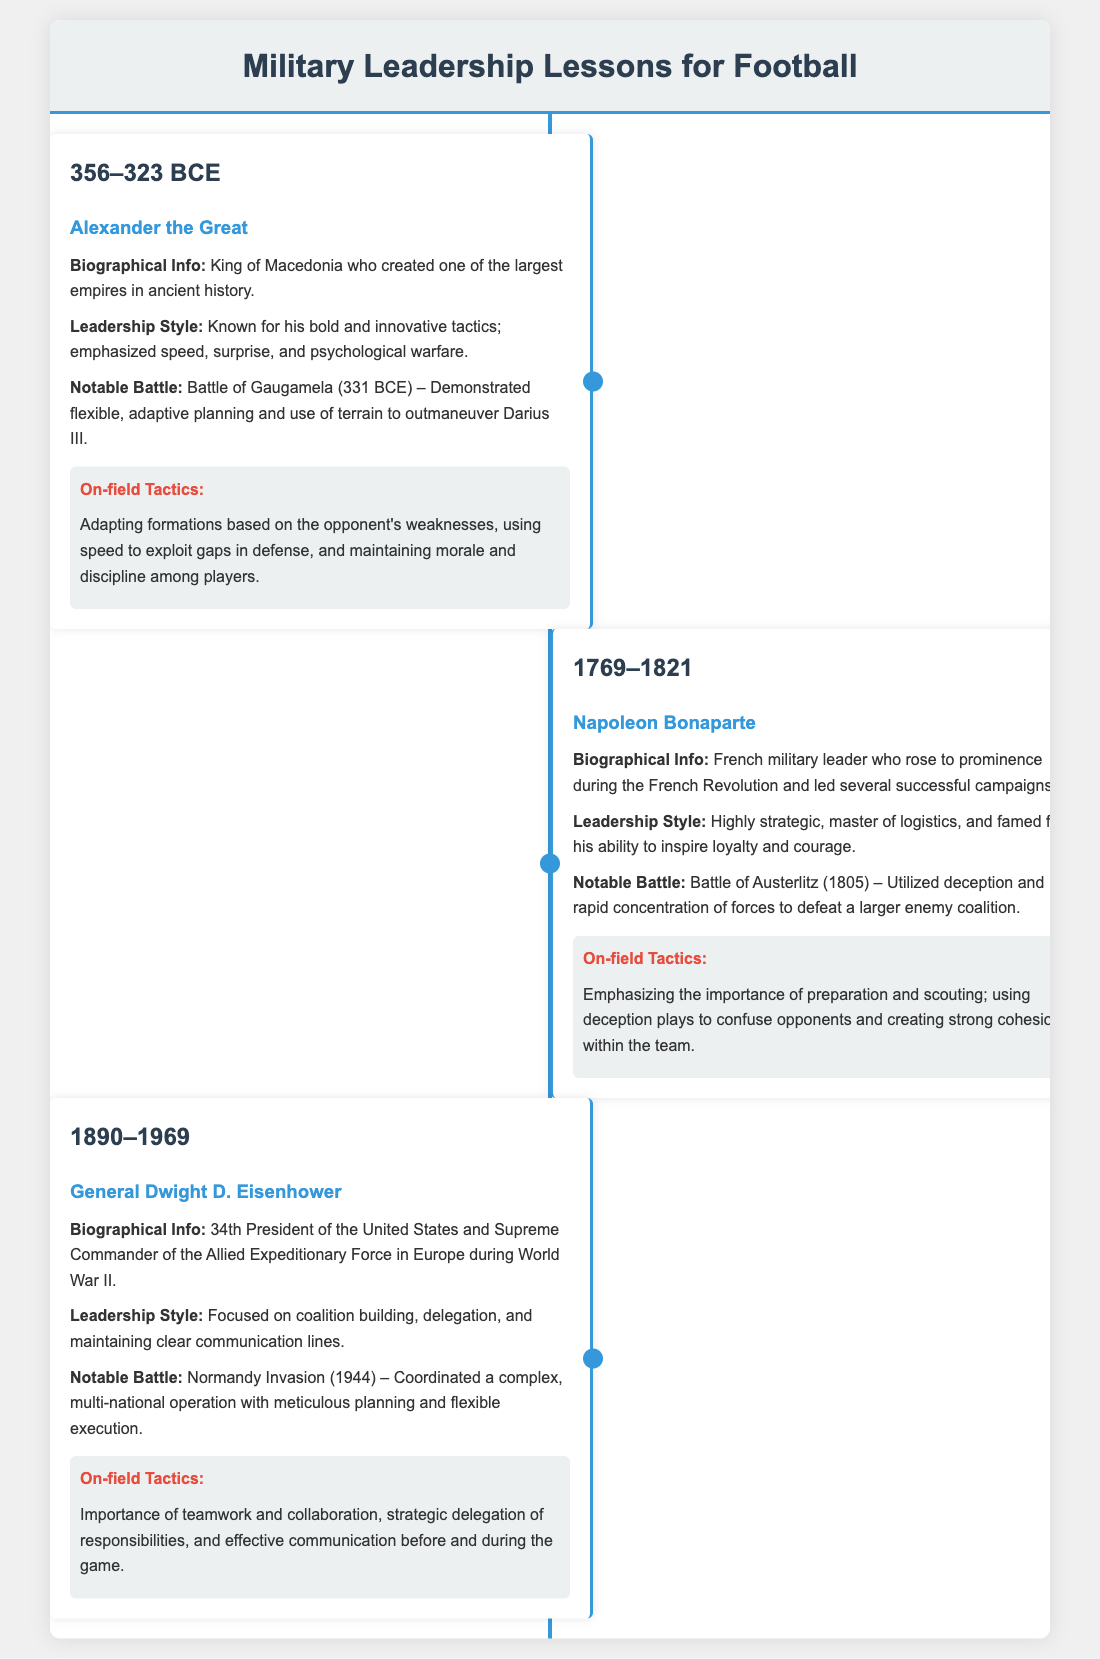What years did Alexander the Great live? The document states that Alexander the Great lived from 356 to 323 BCE.
Answer: 356–323 BCE Who was the Supreme Commander during the Normandy Invasion? The document indicates that General Dwight D. Eisenhower was the Supreme Commander of the Allied Expeditionary Force during this operation.
Answer: General Dwight D. Eisenhower What battle is associated with Napoleon Bonaparte in 1805? The document identifies the Battle of Austerlitz as the notable battle linked to Napoleon Bonaparte in 1805.
Answer: Battle of Austerlitz What key quality did Eisenhower emphasize in his leadership style? The document notes that Eisenhower focused on coalition building as a key quality in his leadership style.
Answer: Coalition building What on-field tactic is connected to Alexander the Great's strategies? The infographic describes that Adapting formations based on the opponent's weaknesses is connected to Alexander's strategies.
Answer: Adapting formations How did Napoleon utilize his forces at the Battle of Austerlitz? The document mentions that Napoleon utilized deception and rapid concentration of forces at the Battle of Austerlitz.
Answer: Deception and rapid concentration of forces What was the notable leadership style of Alexander the Great? The document states that Alexander was known for his bold and innovative tactics.
Answer: Bold and innovative tactics What is one aspect that General Eisenhower emphasized for successful teamwork? The document highlights the importance of effective communication as an aspect of successful teamwork.
Answer: Effective communication What kind of tactics did Napoleon Bonaparte stress for football teams? The document states that Napoleon emphasized the importance of preparation and scouting for football teams.
Answer: Preparation and scouting 